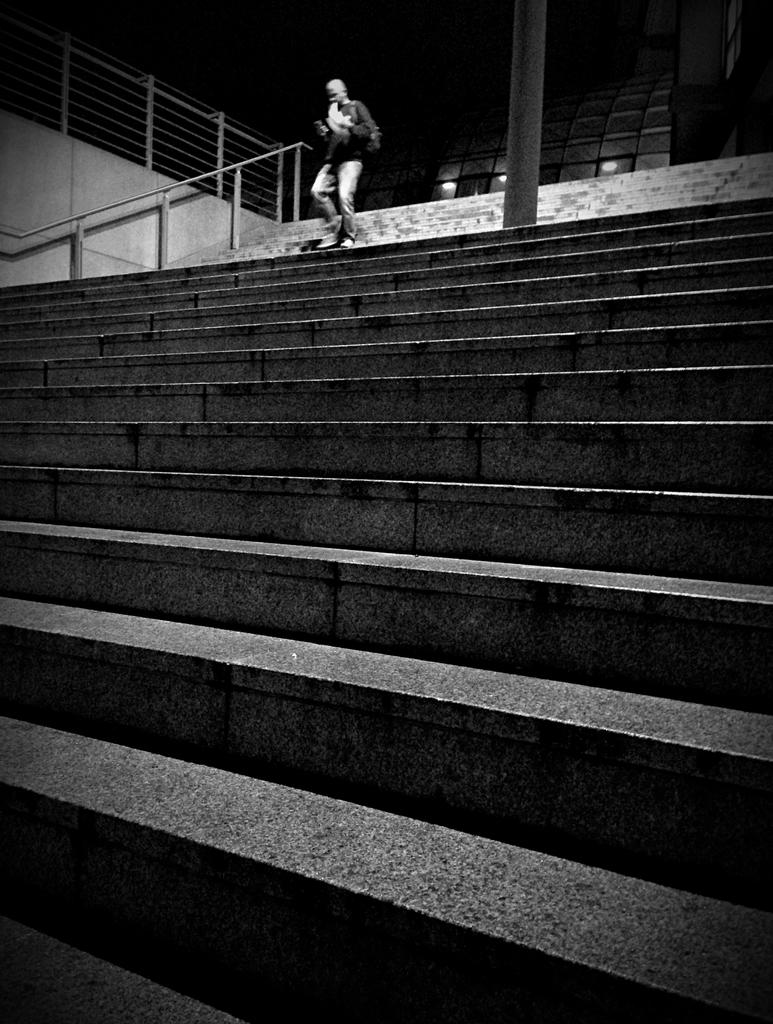What is the color scheme of the image? The image is black and white. Who is present in the image? There is a man in the image. What is the man wearing? The man is wearing a bag. What is the man holding? The man is holding papers. What architectural features can be seen in the image? There are stairs, a fence, and a pole in the image. What lighting elements are present in the image? There are lights in the image. What type of windows are visible in the image? There are glass windows in the image. What type of tax does the man discuss with his brother in the image? There is no mention of tax or a brother in the image; it only features a man holding papers and standing near stairs, a fence, and a pole. 